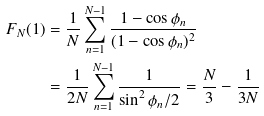<formula> <loc_0><loc_0><loc_500><loc_500>F _ { N } ( 1 ) & = \frac { 1 } { N } \sum ^ { N - 1 } _ { n = 1 } \frac { 1 - \cos \phi _ { n } } { ( 1 - \cos \phi _ { n } ) ^ { 2 } } \\ & = \frac { 1 } { 2 N } \sum ^ { N - 1 } _ { n = 1 } \frac { 1 } { \sin ^ { 2 } \phi _ { n } / 2 } = \frac { N } { 3 } - \frac { 1 } { 3 N }</formula> 